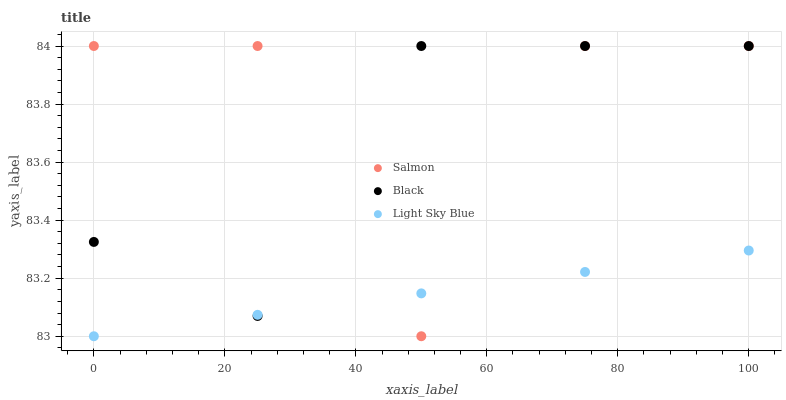Does Light Sky Blue have the minimum area under the curve?
Answer yes or no. Yes. Does Salmon have the maximum area under the curve?
Answer yes or no. Yes. Does Salmon have the minimum area under the curve?
Answer yes or no. No. Does Light Sky Blue have the maximum area under the curve?
Answer yes or no. No. Is Light Sky Blue the smoothest?
Answer yes or no. Yes. Is Salmon the roughest?
Answer yes or no. Yes. Is Salmon the smoothest?
Answer yes or no. No. Is Light Sky Blue the roughest?
Answer yes or no. No. Does Light Sky Blue have the lowest value?
Answer yes or no. Yes. Does Salmon have the lowest value?
Answer yes or no. No. Does Salmon have the highest value?
Answer yes or no. Yes. Does Light Sky Blue have the highest value?
Answer yes or no. No. Does Light Sky Blue intersect Salmon?
Answer yes or no. Yes. Is Light Sky Blue less than Salmon?
Answer yes or no. No. Is Light Sky Blue greater than Salmon?
Answer yes or no. No. 